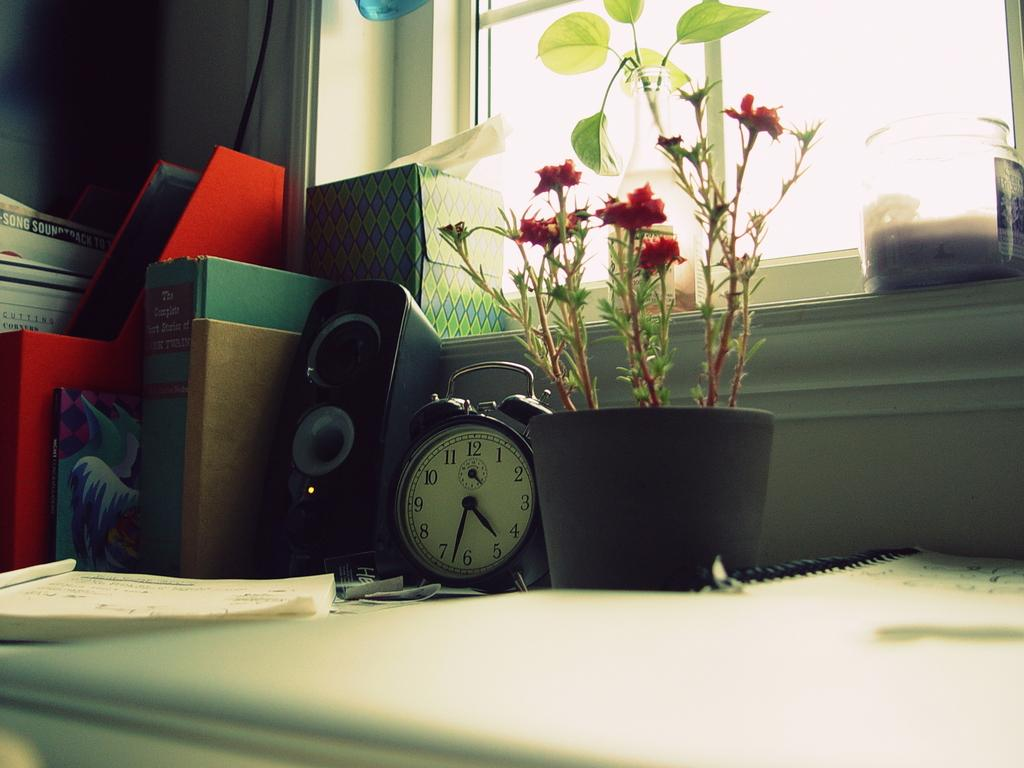<image>
Render a clear and concise summary of the photo. A clock on a shelf has the time of 4:32. 